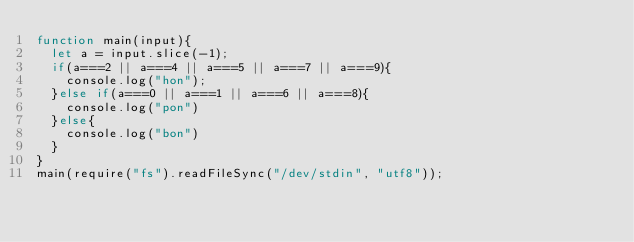Convert code to text. <code><loc_0><loc_0><loc_500><loc_500><_JavaScript_>function main(input){
  let a = input.slice(-1);
  if(a===2 || a===4 || a===5 || a===7 || a===9){
    console.log("hon");
  }else if(a===0 || a===1 || a===6 || a===8){
    console.log("pon")
  }else{
    console.log("bon")
  }
}
main(require("fs").readFileSync("/dev/stdin", "utf8"));</code> 